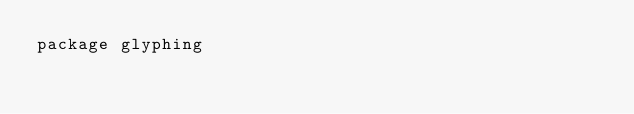<code> <loc_0><loc_0><loc_500><loc_500><_Go_>package glyphing
</code> 